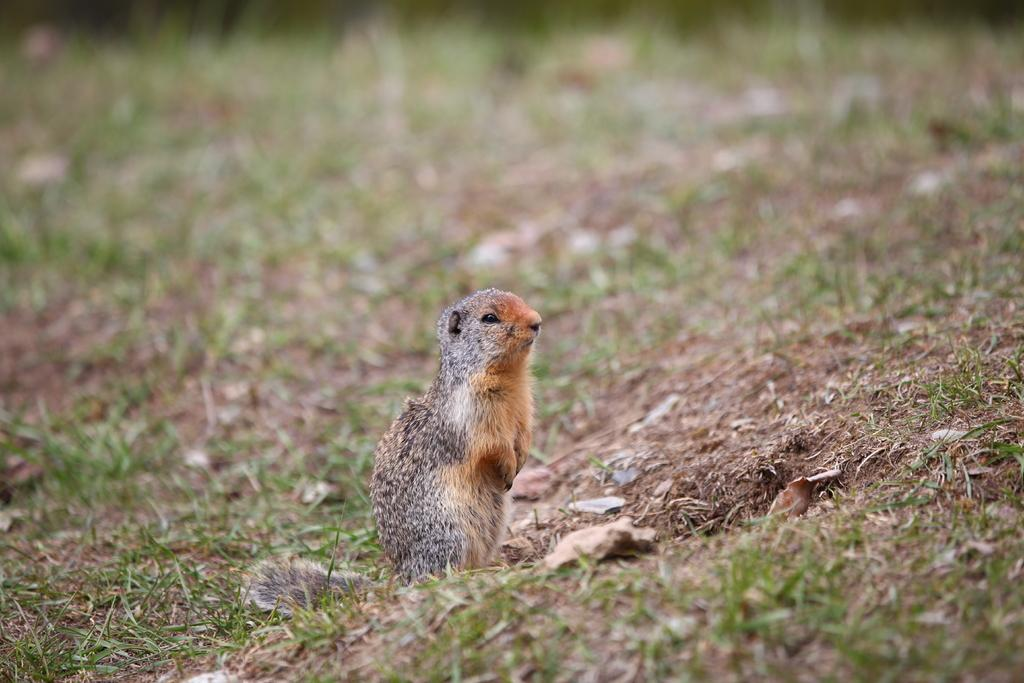What type of animal can be seen in the image? There is a squirrel in the image. What type of vegetation is present in the image? There is grass in the image. What else can be seen on the ground in the image? Dried leaves are lying on the ground in the image. Can you see a ball floating in the river in the image? A: There is no river or ball present in the image; it features a squirrel, grass, and dried leaves. 